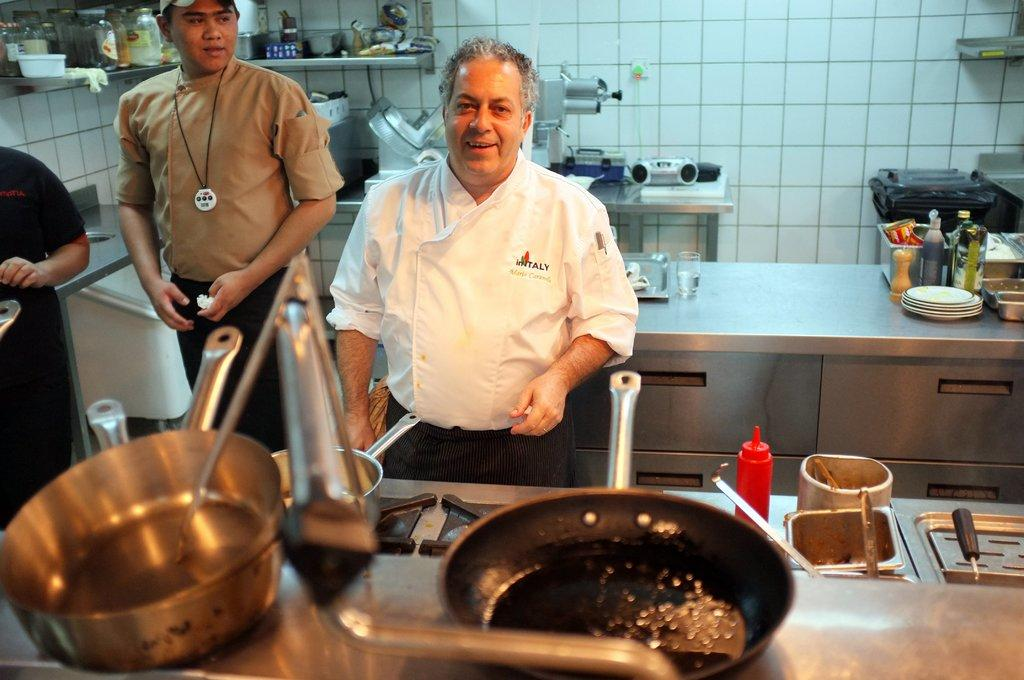How many people are in the image? There are three people in the image. What are the two men doing in the image? The two men are standing and smiling. What type of kitchenware can be seen in the image? There is a pan, bowls, bottles, plates, and jars in the image. What else can be seen in the image besides the people and kitchenware? There are other objects in the image. What is visible in the background of the image? There is a wall in the background of the image. What type of camping equipment can be seen in the image? There is no camping equipment present in the image. What is the main dish being served for dinner in the image? The image does not depict a dinner scene, so it is not possible to determine the main dish being served. 